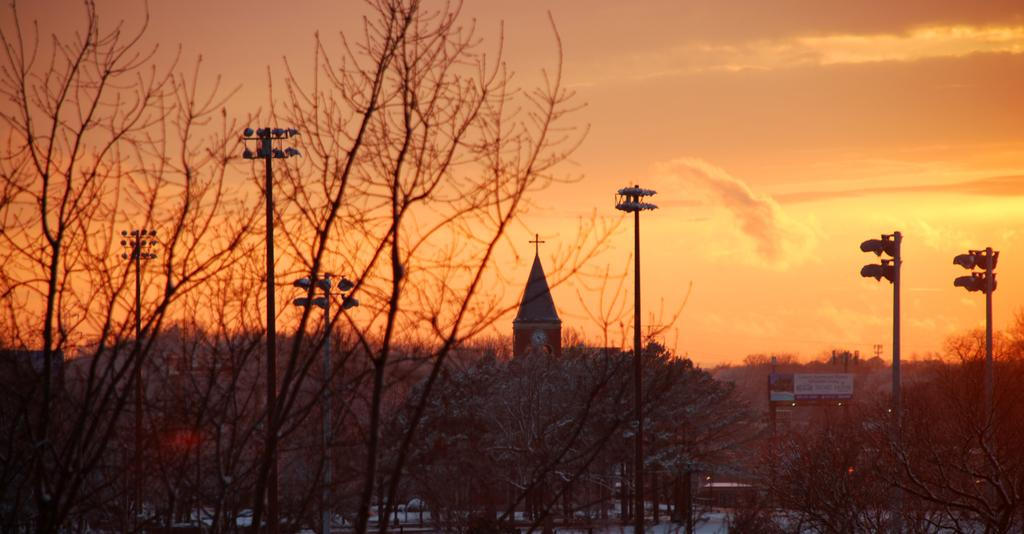What type of natural elements can be seen in the image? There are trees in the image. What man-made structures are present in the image? There are poles, buildings, and boards with text in the image. What part of the natural environment is visible in the image? The sky is visible in the image. What type of zinc object can be seen in the image? There is no zinc object present in the image. What type of dinner is being served in the image? There is no dinner being served in the image. 